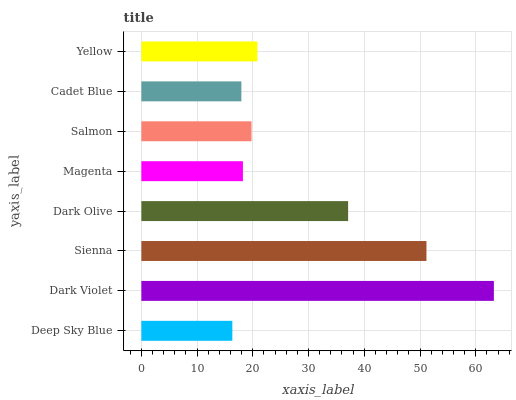Is Deep Sky Blue the minimum?
Answer yes or no. Yes. Is Dark Violet the maximum?
Answer yes or no. Yes. Is Sienna the minimum?
Answer yes or no. No. Is Sienna the maximum?
Answer yes or no. No. Is Dark Violet greater than Sienna?
Answer yes or no. Yes. Is Sienna less than Dark Violet?
Answer yes or no. Yes. Is Sienna greater than Dark Violet?
Answer yes or no. No. Is Dark Violet less than Sienna?
Answer yes or no. No. Is Yellow the high median?
Answer yes or no. Yes. Is Salmon the low median?
Answer yes or no. Yes. Is Salmon the high median?
Answer yes or no. No. Is Yellow the low median?
Answer yes or no. No. 